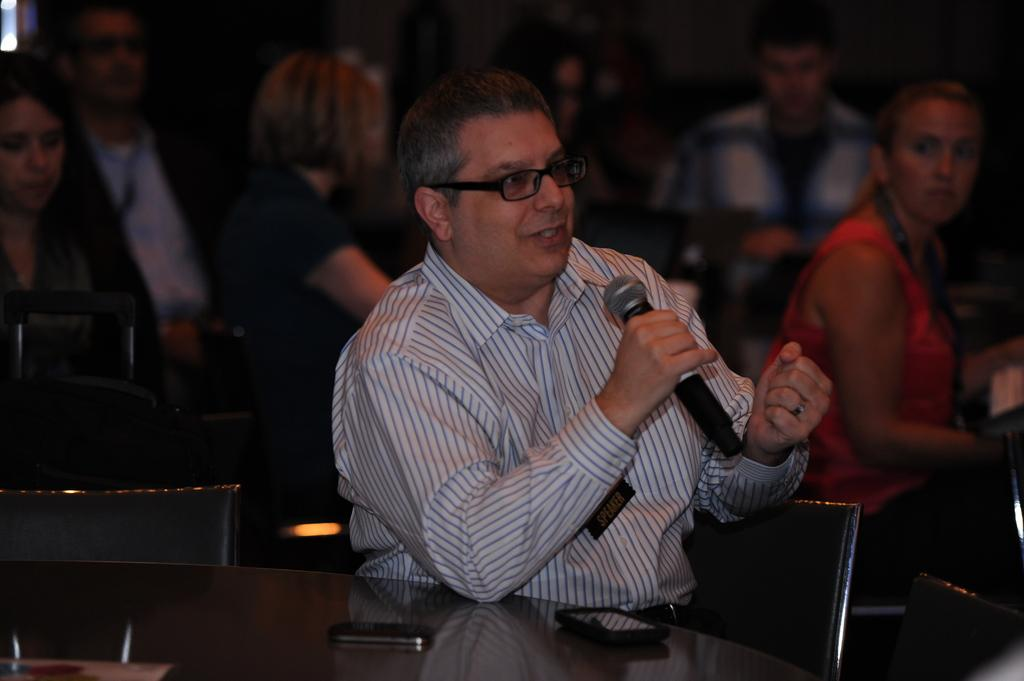What is the main subject in the foreground of the image? There is a person sitting in a chair in the foreground of the image. What is the person in the foreground holding? The person is holding a mic. Can you describe the people in the background of the image? The people in the background are visible, but they are not clear. What type of shade does the grandfather prefer in the image? There is no grandfather present in the image, and therefore no preference for shade can be determined. 